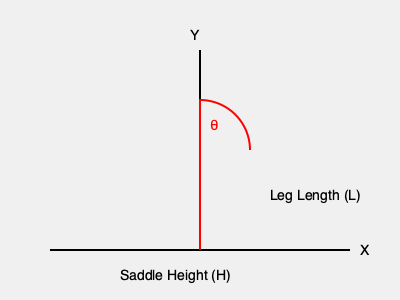You're preparing for your first horse riding lesson and want to ensure your saddle is at the right height. Given that the optimal saddle height (H) is calculated using the formula $H = L \times \sin(\theta)$, where L is your leg length and $\theta$ (theta) is the optimal pedaling angle of 25°, what would be your ideal saddle height if your leg length is 32 inches? To calculate the optimal saddle height, we'll follow these steps:

1. Identify the given information:
   - Leg length (L) = 32 inches
   - Optimal pedaling angle ($\theta$) = 25°
   - Formula: $H = L \times \sin(\theta)$

2. Convert the angle to radians (optional, depending on your calculator):
   $25° = 25 \times \frac{\pi}{180} \approx 0.4363$ radians

3. Calculate $\sin(\theta)$:
   $\sin(25°) \approx 0.4226$

4. Apply the formula:
   $H = L \times \sin(\theta)$
   $H = 32 \times 0.4226$
   $H \approx 13.5232$ inches

5. Round to a practical measurement:
   $H \approx 13.5$ inches

Therefore, the optimal saddle height for your leg length would be approximately 13.5 inches.
Answer: 13.5 inches 